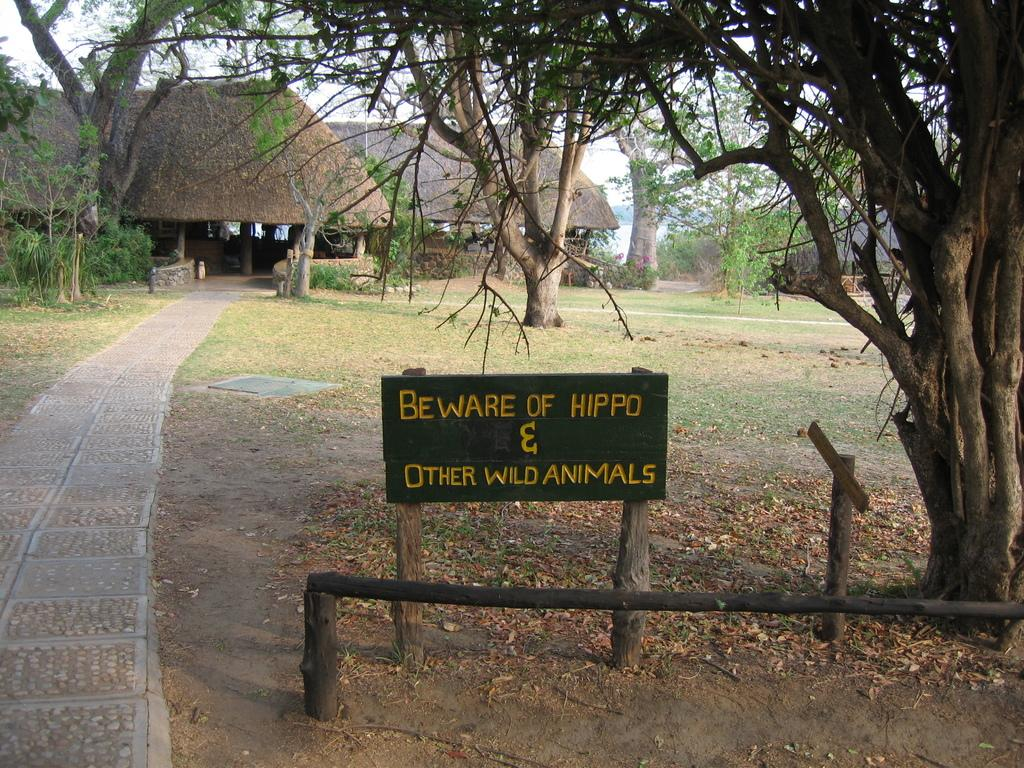What can be seen in the sky in the image? The sky is visible in the image. What type of vegetation is present in the image? There are trees in the image. What type of structures can be seen in the image? There are thatched sheds in the image. What kind of path is visible in the image? There is a walking path in the image. What material is present on the ground in the image? Shredded leaves are present on the ground in the image. What additional feature can be found in the image? There is an information board in the image. What type of furniture is being offered by the kitty in the image? There is no kitty present in the image, and therefore no furniture is being offered. 